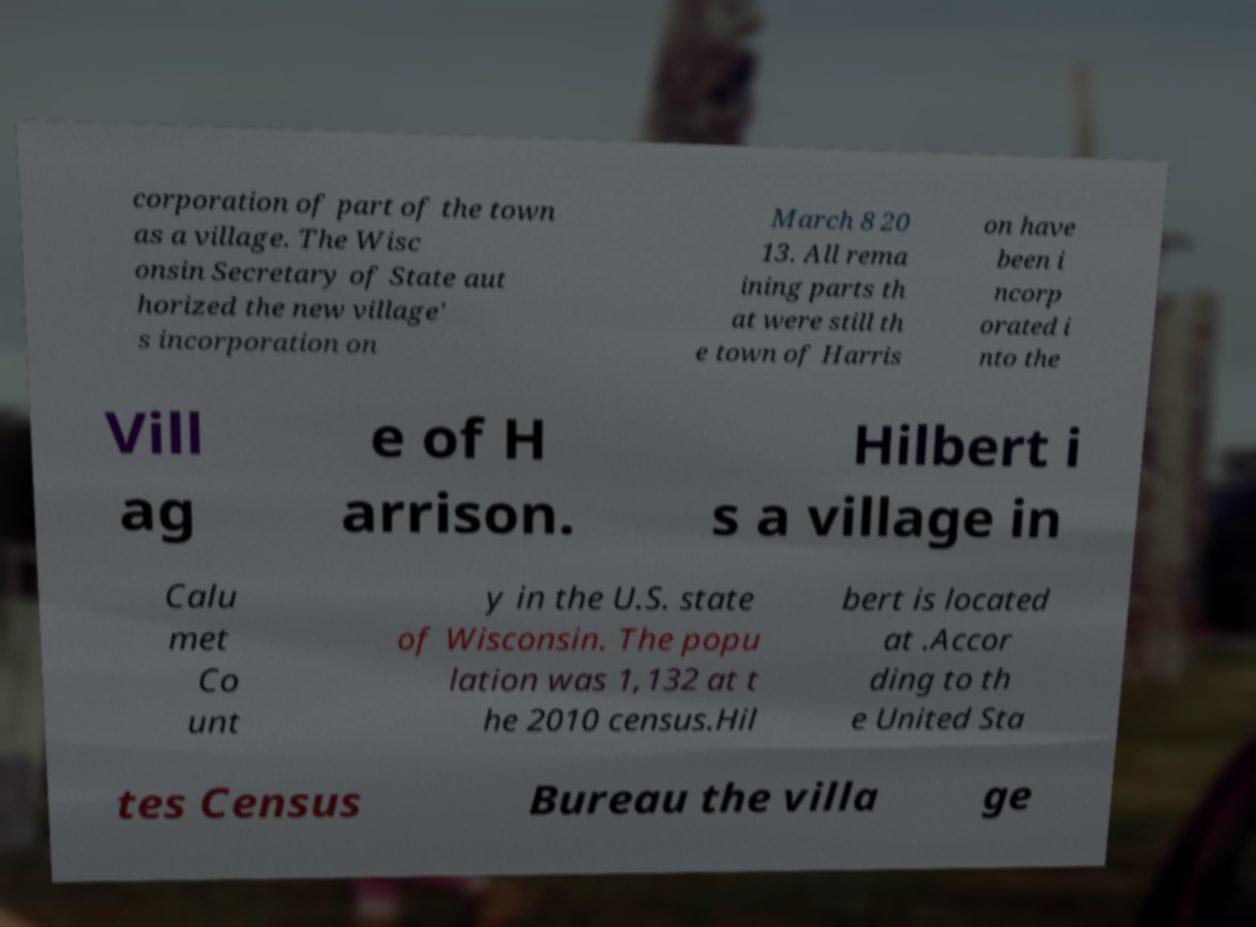Can you read and provide the text displayed in the image?This photo seems to have some interesting text. Can you extract and type it out for me? corporation of part of the town as a village. The Wisc onsin Secretary of State aut horized the new village' s incorporation on March 8 20 13. All rema ining parts th at were still th e town of Harris on have been i ncorp orated i nto the Vill ag e of H arrison. Hilbert i s a village in Calu met Co unt y in the U.S. state of Wisconsin. The popu lation was 1,132 at t he 2010 census.Hil bert is located at .Accor ding to th e United Sta tes Census Bureau the villa ge 